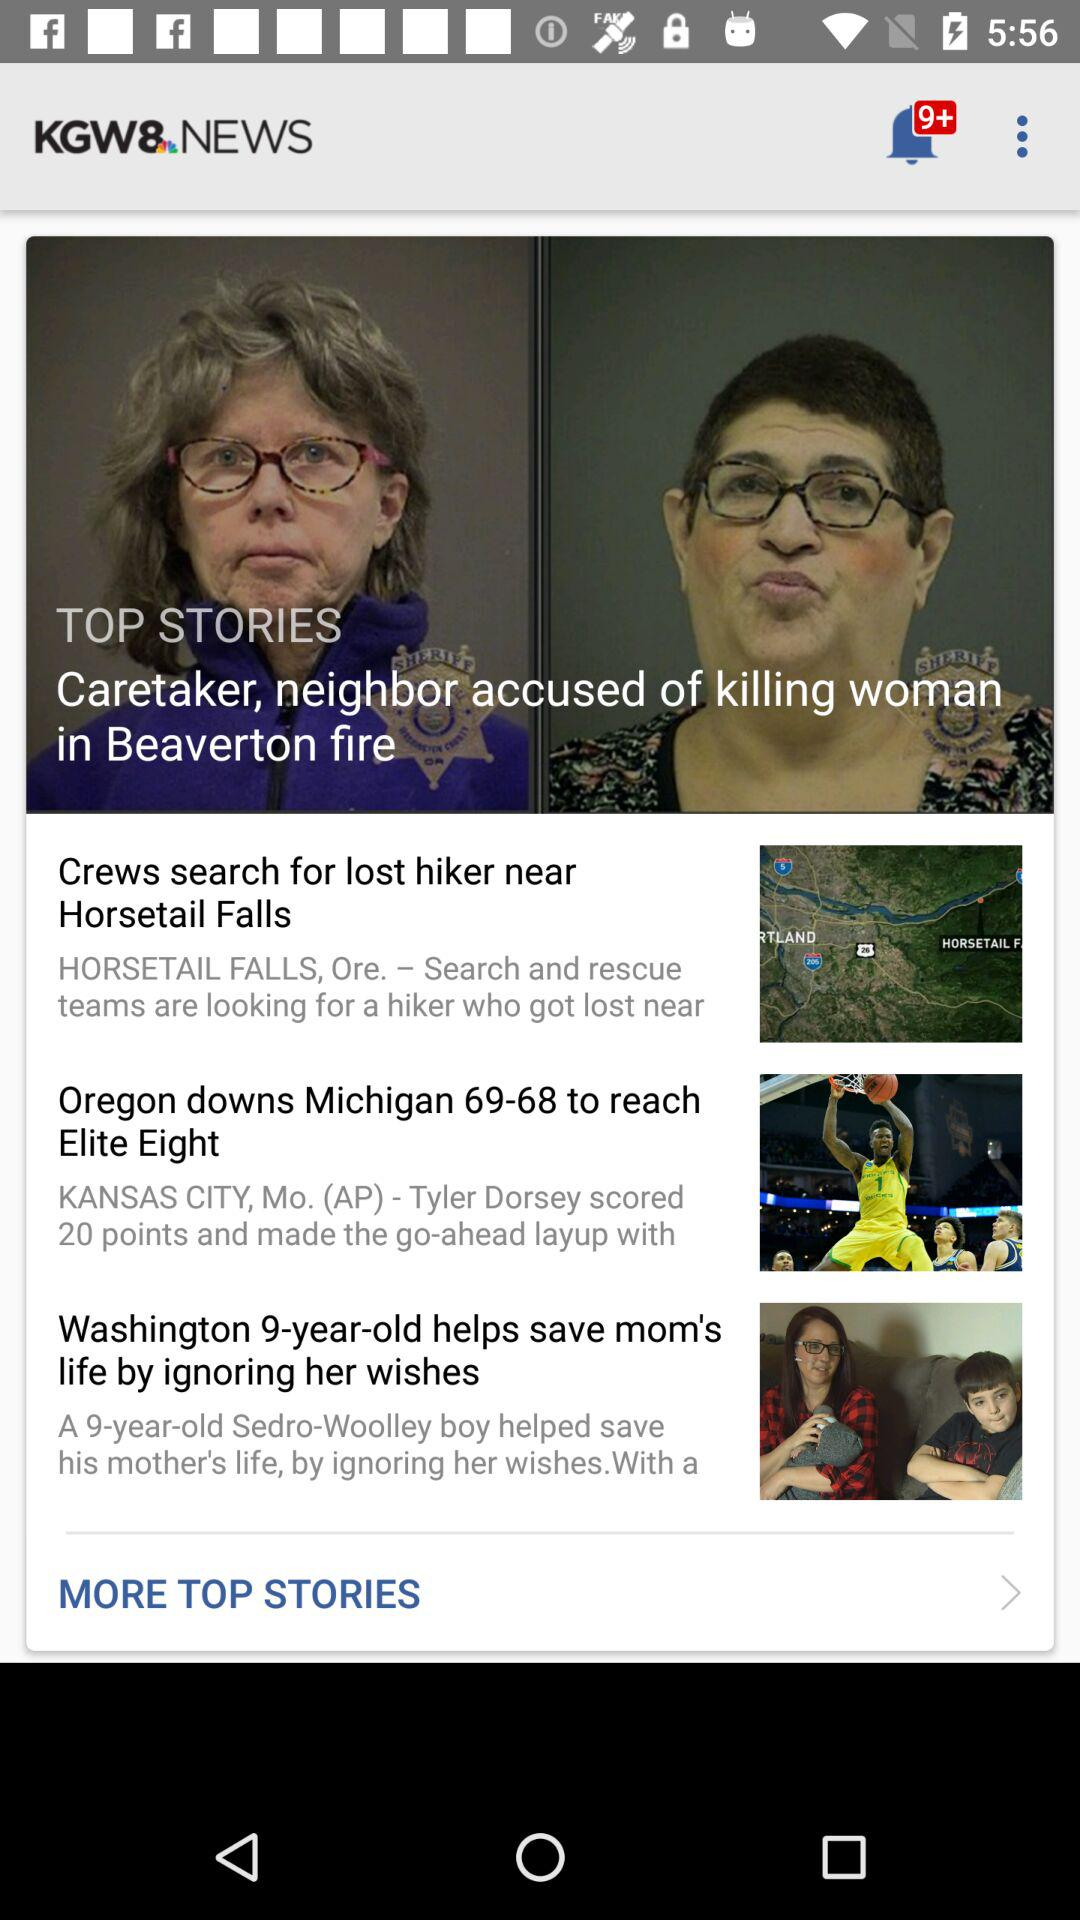What is the headline of the article? The headlines of the article are "Caretaker, neighbor accused of killing woman in Beaverton fire", "Crews search for lost hiker near Horsetail Falls", "Oregon downs Michigan 69-68 to reach Elite Eight" and "Washington 9-year-old helps save mom's life by ignoring her wishes". 